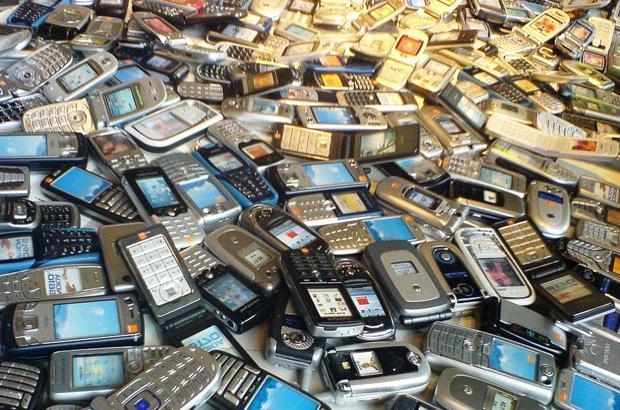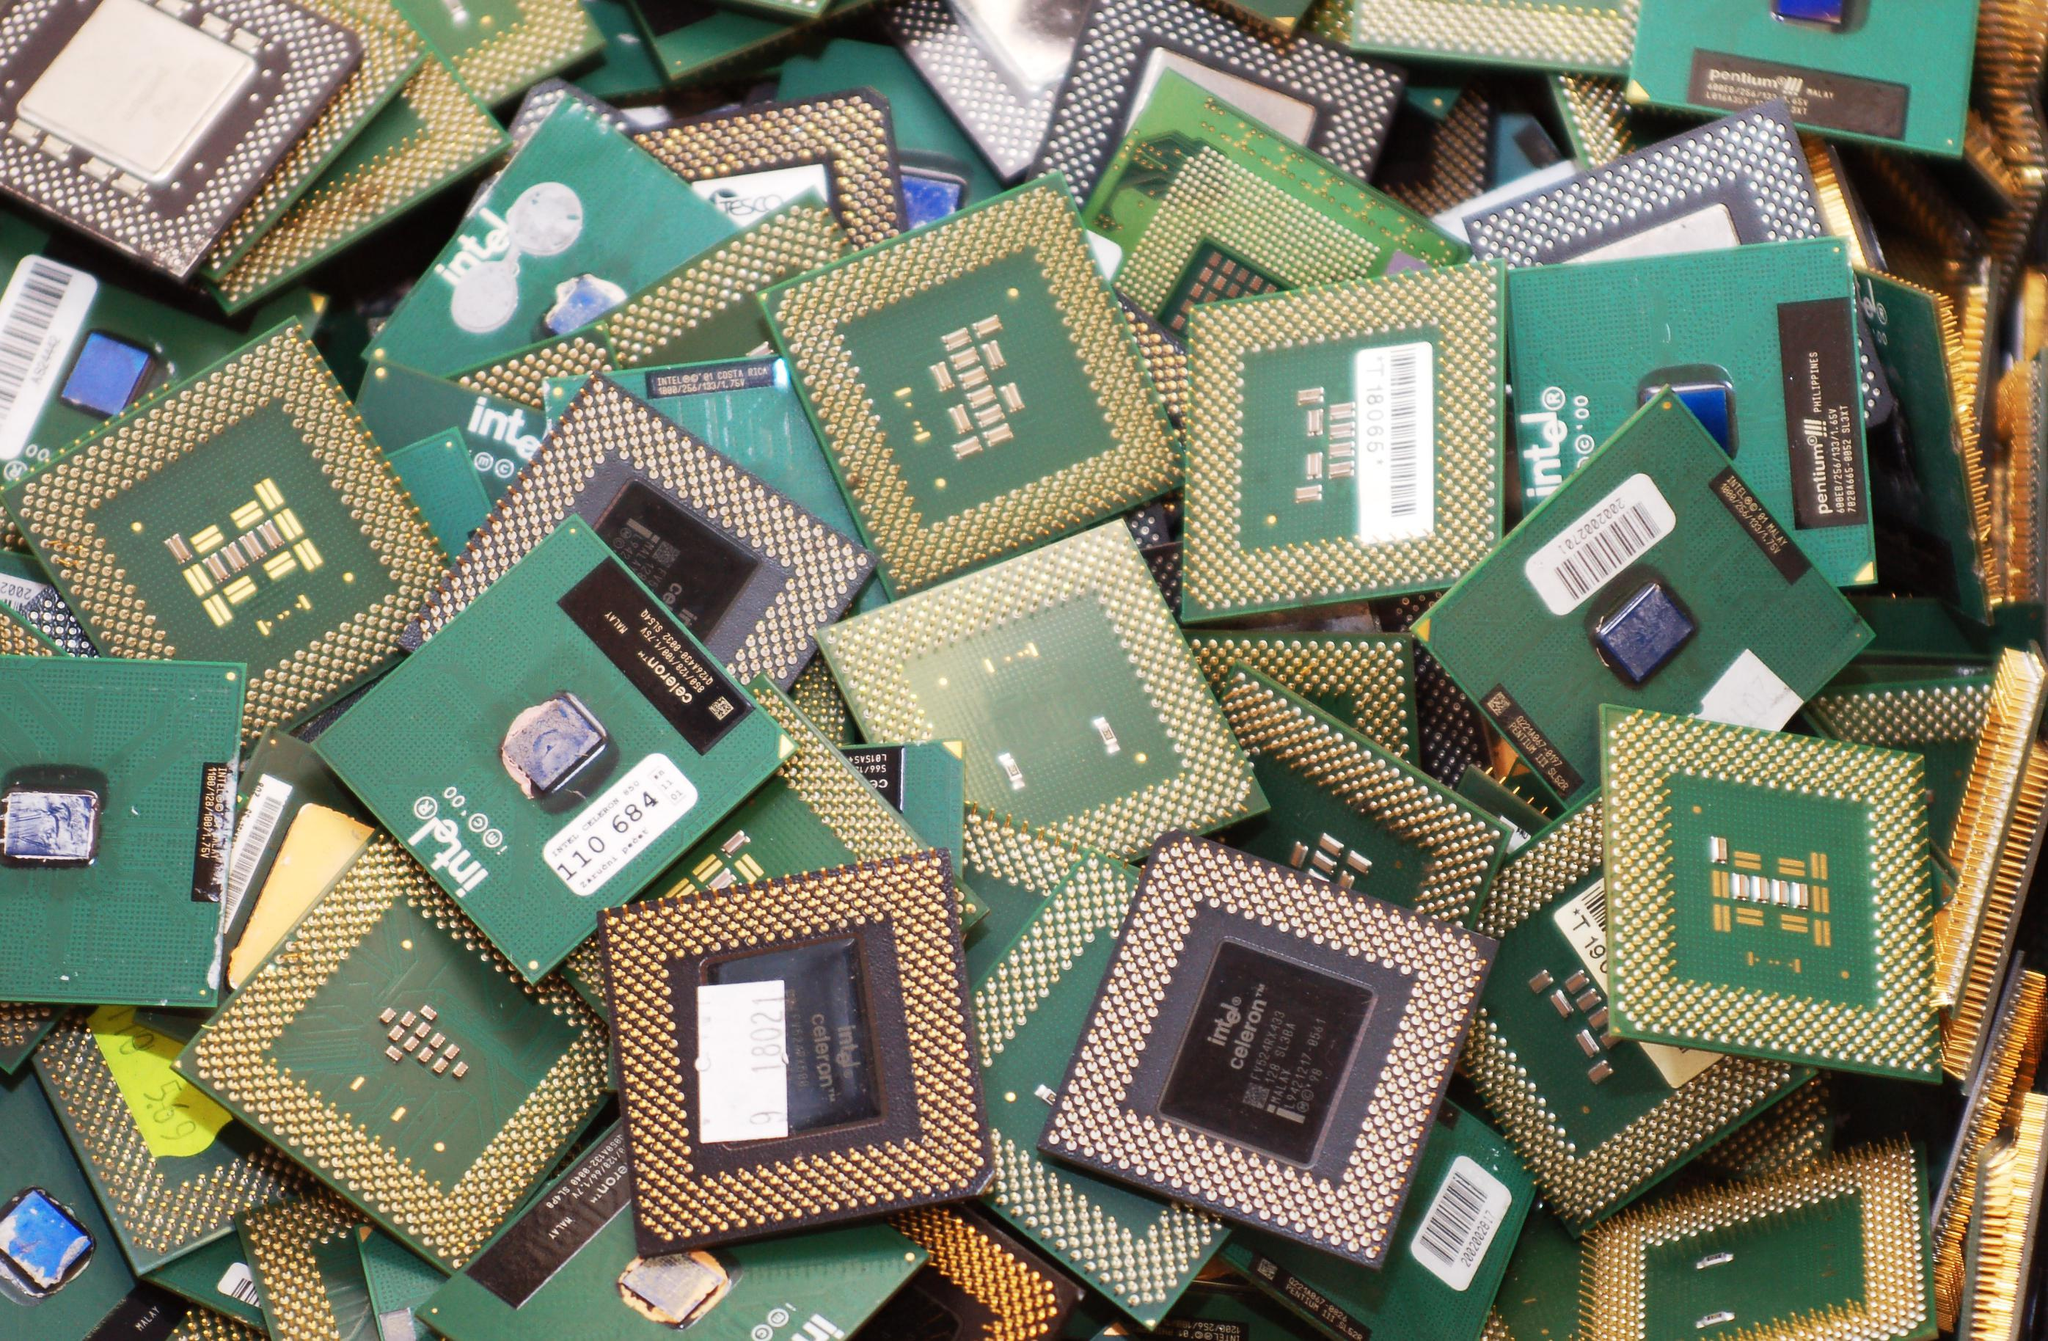The first image is the image on the left, the second image is the image on the right. Examine the images to the left and right. Is the description "The left image shows a pile of phones in a visible container with sides, and the right image shows a pile of phones - including at least two blue ones - with no container." accurate? Answer yes or no. No. 